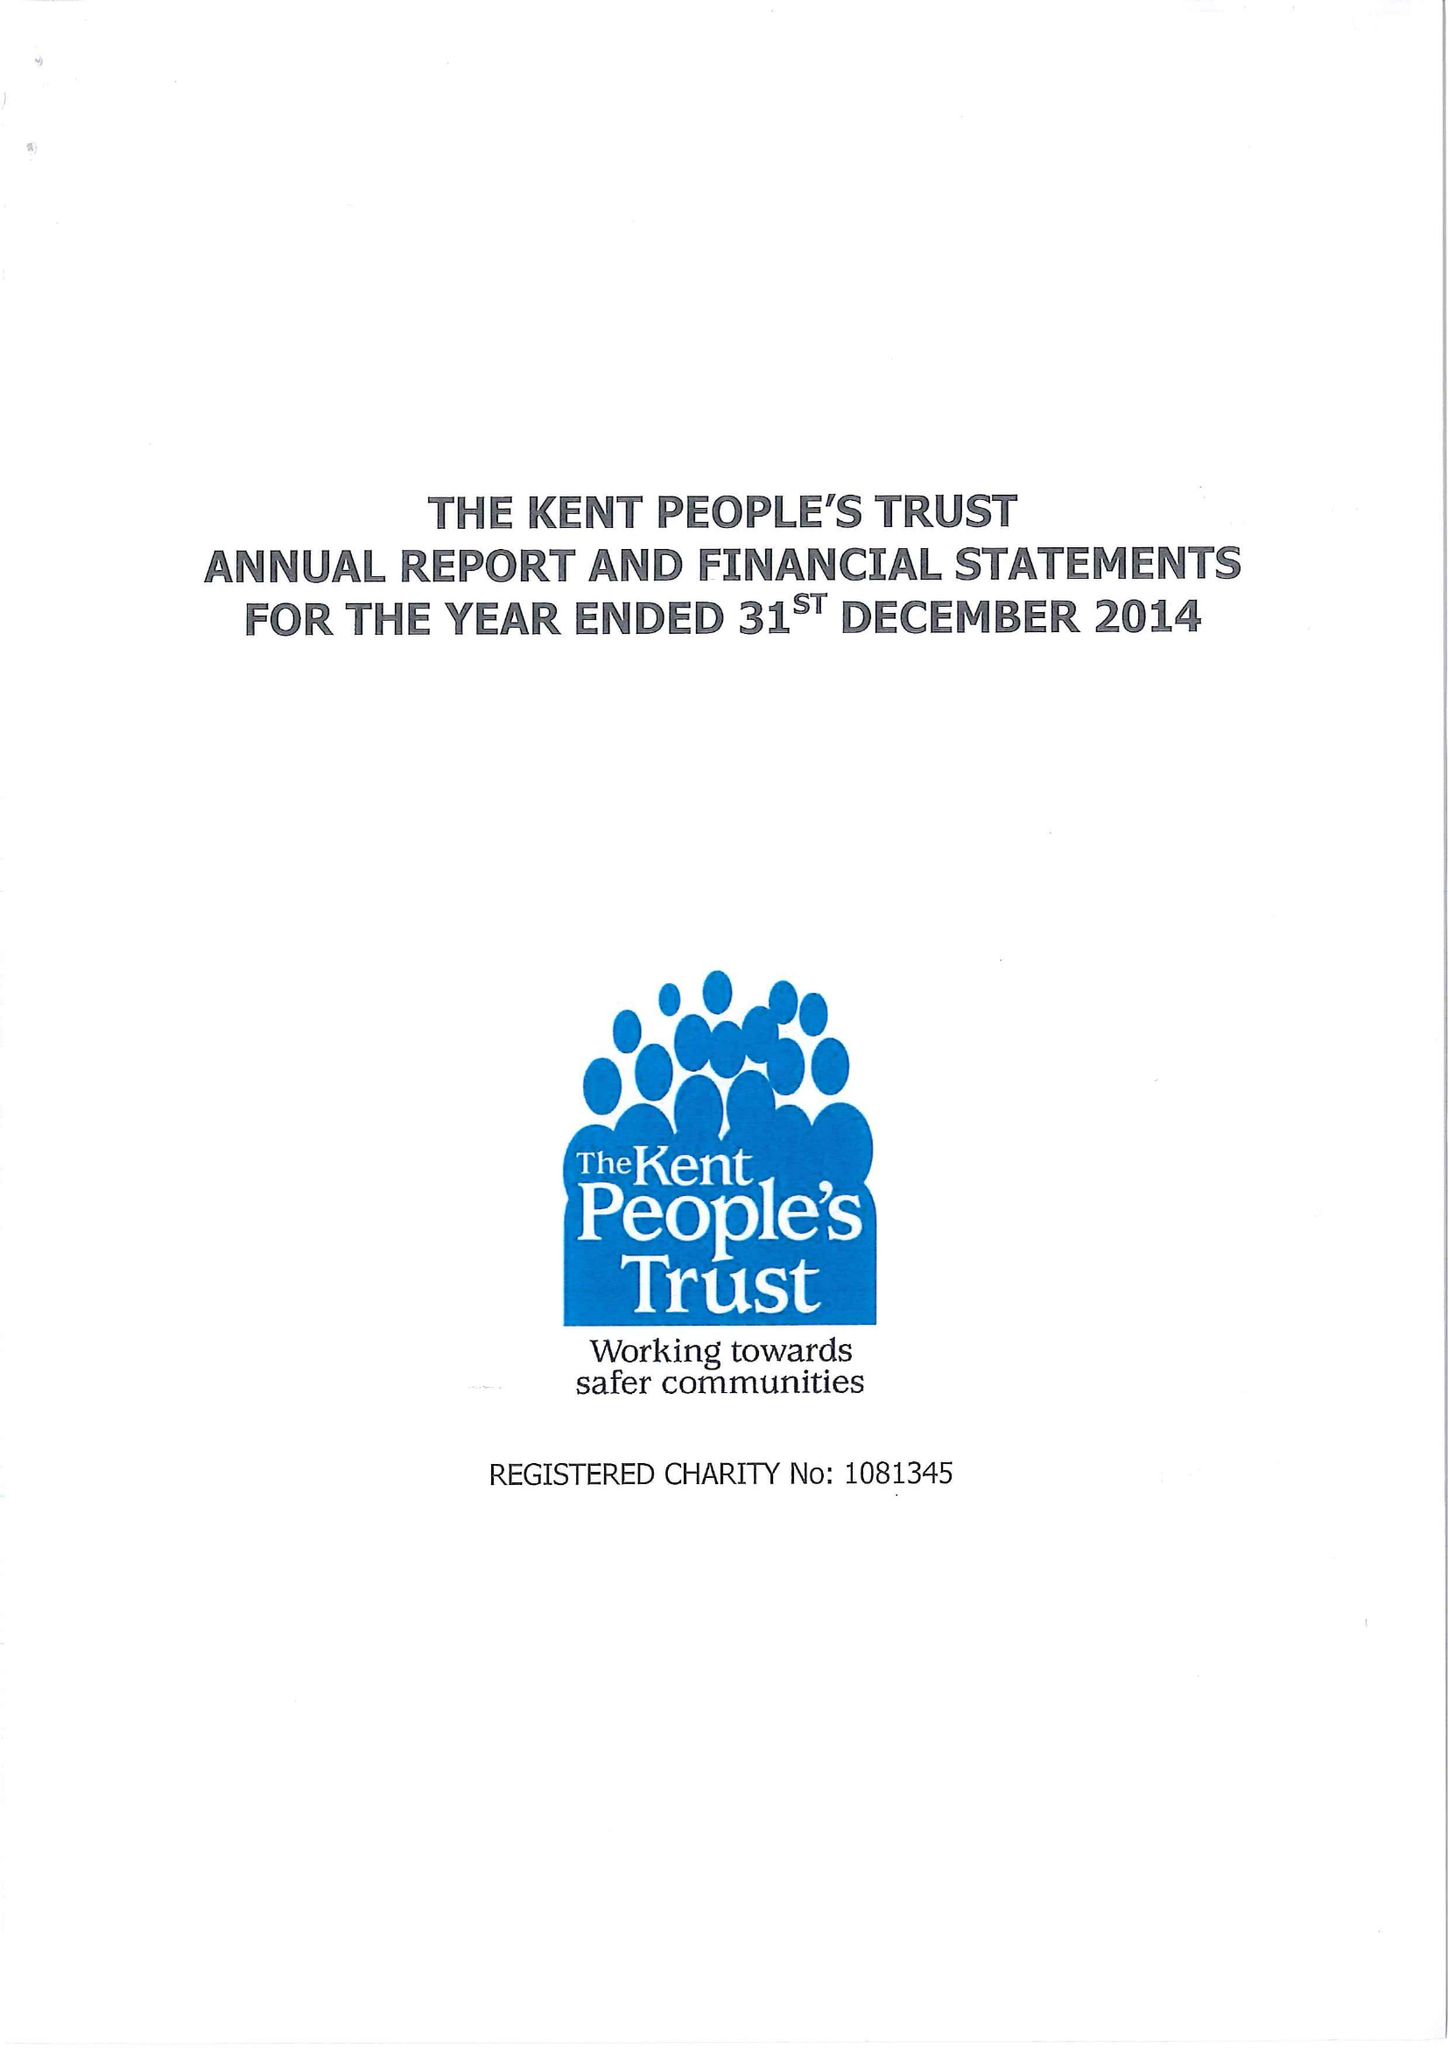What is the value for the charity_name?
Answer the question using a single word or phrase. The Kent People's Trust 